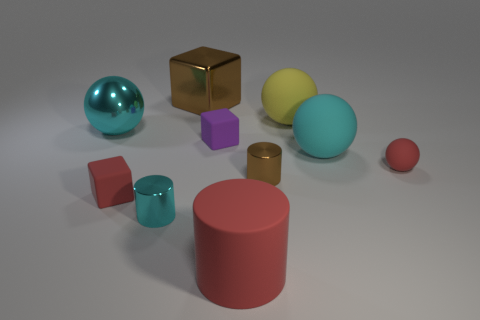Subtract all cylinders. How many objects are left? 7 Add 1 large red rubber cylinders. How many large red rubber cylinders exist? 2 Subtract 0 purple cylinders. How many objects are left? 10 Subtract all small gray rubber cubes. Subtract all red cylinders. How many objects are left? 9 Add 1 small rubber balls. How many small rubber balls are left? 2 